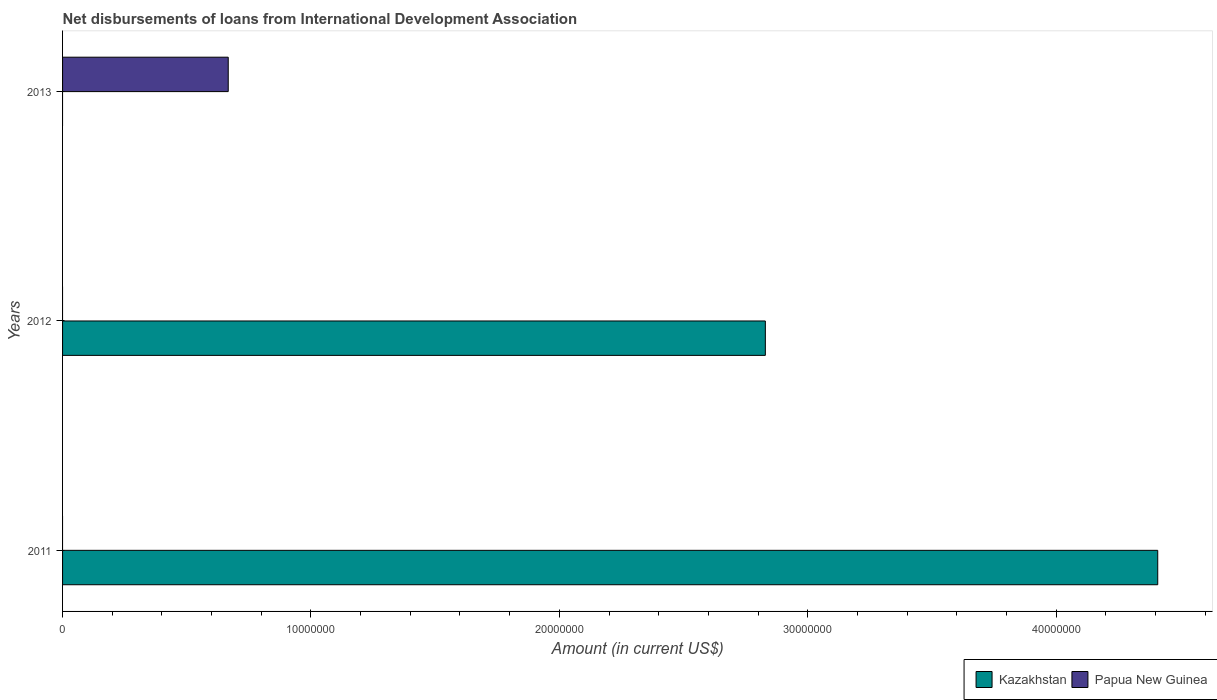How many different coloured bars are there?
Provide a short and direct response. 2. Are the number of bars per tick equal to the number of legend labels?
Offer a terse response. No. Are the number of bars on each tick of the Y-axis equal?
Your response must be concise. Yes. How many bars are there on the 2nd tick from the top?
Provide a succinct answer. 1. How many bars are there on the 2nd tick from the bottom?
Provide a short and direct response. 1. What is the amount of loans disbursed in Kazakhstan in 2012?
Provide a succinct answer. 2.83e+07. Across all years, what is the maximum amount of loans disbursed in Papua New Guinea?
Give a very brief answer. 6.67e+06. Across all years, what is the minimum amount of loans disbursed in Papua New Guinea?
Keep it short and to the point. 0. What is the total amount of loans disbursed in Papua New Guinea in the graph?
Keep it short and to the point. 6.67e+06. What is the difference between the amount of loans disbursed in Kazakhstan in 2011 and that in 2012?
Your answer should be compact. 1.58e+07. What is the difference between the amount of loans disbursed in Kazakhstan in 2011 and the amount of loans disbursed in Papua New Guinea in 2012?
Give a very brief answer. 4.41e+07. What is the average amount of loans disbursed in Kazakhstan per year?
Keep it short and to the point. 2.41e+07. What is the ratio of the amount of loans disbursed in Kazakhstan in 2011 to that in 2012?
Keep it short and to the point. 1.56. What is the difference between the highest and the lowest amount of loans disbursed in Kazakhstan?
Provide a succinct answer. 4.41e+07. Is the sum of the amount of loans disbursed in Kazakhstan in 2011 and 2012 greater than the maximum amount of loans disbursed in Papua New Guinea across all years?
Ensure brevity in your answer.  Yes. How many years are there in the graph?
Your response must be concise. 3. Does the graph contain any zero values?
Give a very brief answer. Yes. How are the legend labels stacked?
Provide a short and direct response. Horizontal. What is the title of the graph?
Make the answer very short. Net disbursements of loans from International Development Association. What is the label or title of the X-axis?
Give a very brief answer. Amount (in current US$). What is the Amount (in current US$) in Kazakhstan in 2011?
Your response must be concise. 4.41e+07. What is the Amount (in current US$) in Papua New Guinea in 2011?
Ensure brevity in your answer.  0. What is the Amount (in current US$) of Kazakhstan in 2012?
Keep it short and to the point. 2.83e+07. What is the Amount (in current US$) of Kazakhstan in 2013?
Provide a short and direct response. 0. What is the Amount (in current US$) of Papua New Guinea in 2013?
Provide a succinct answer. 6.67e+06. Across all years, what is the maximum Amount (in current US$) of Kazakhstan?
Offer a terse response. 4.41e+07. Across all years, what is the maximum Amount (in current US$) in Papua New Guinea?
Keep it short and to the point. 6.67e+06. Across all years, what is the minimum Amount (in current US$) in Papua New Guinea?
Offer a very short reply. 0. What is the total Amount (in current US$) in Kazakhstan in the graph?
Your answer should be very brief. 7.24e+07. What is the total Amount (in current US$) of Papua New Guinea in the graph?
Give a very brief answer. 6.67e+06. What is the difference between the Amount (in current US$) of Kazakhstan in 2011 and that in 2012?
Your answer should be compact. 1.58e+07. What is the difference between the Amount (in current US$) in Kazakhstan in 2011 and the Amount (in current US$) in Papua New Guinea in 2013?
Make the answer very short. 3.74e+07. What is the difference between the Amount (in current US$) in Kazakhstan in 2012 and the Amount (in current US$) in Papua New Guinea in 2013?
Keep it short and to the point. 2.16e+07. What is the average Amount (in current US$) of Kazakhstan per year?
Offer a very short reply. 2.41e+07. What is the average Amount (in current US$) in Papua New Guinea per year?
Your answer should be very brief. 2.22e+06. What is the ratio of the Amount (in current US$) of Kazakhstan in 2011 to that in 2012?
Offer a terse response. 1.56. What is the difference between the highest and the lowest Amount (in current US$) of Kazakhstan?
Your answer should be compact. 4.41e+07. What is the difference between the highest and the lowest Amount (in current US$) of Papua New Guinea?
Offer a very short reply. 6.67e+06. 